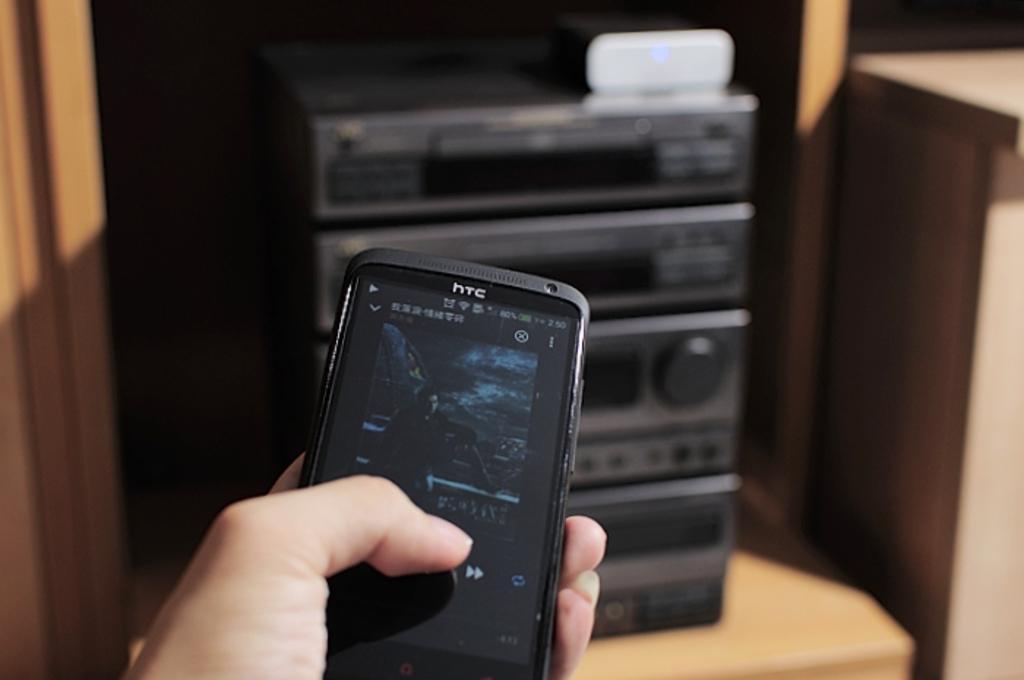Describe this image in one or two sentences. In this image we can see some person holding a HTC mobile phone. In the background we can see a home theatre on the wooden surface. 